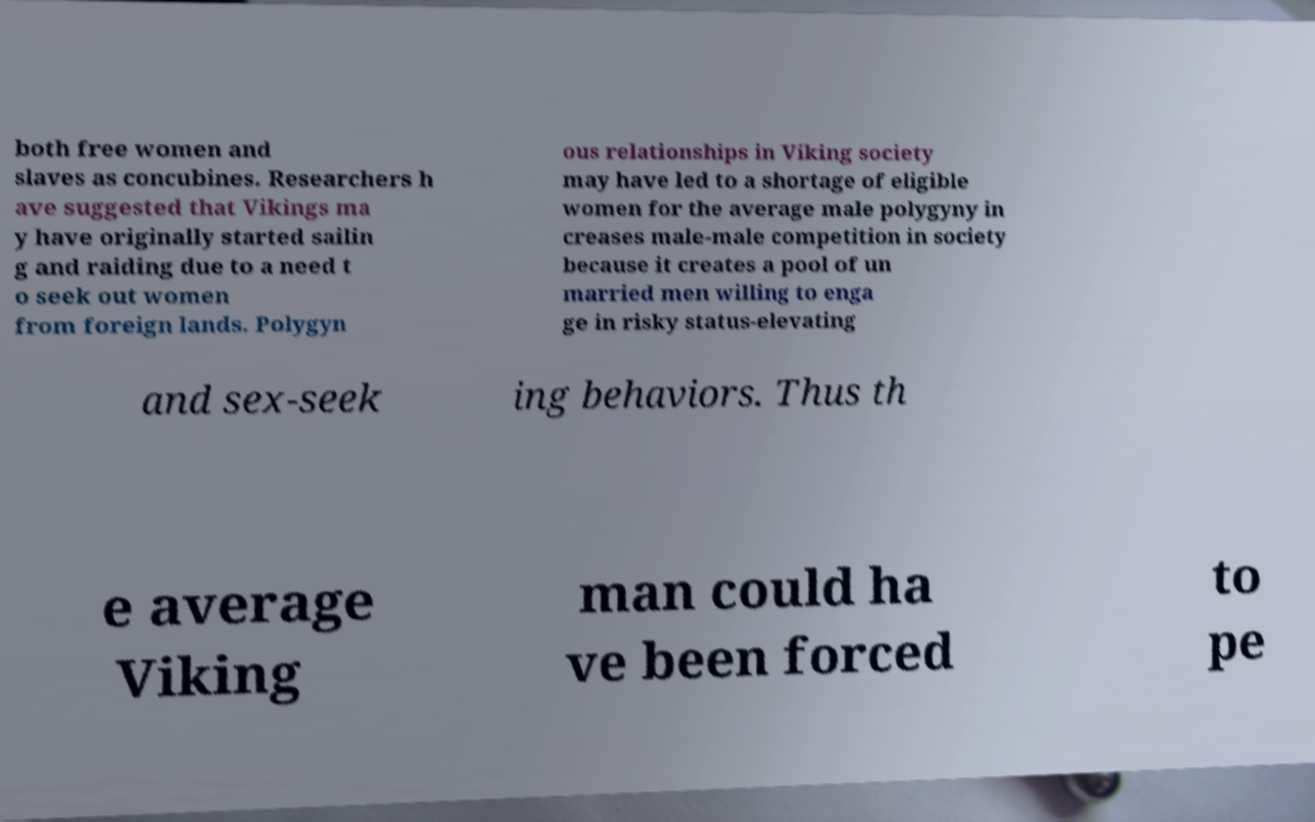For documentation purposes, I need the text within this image transcribed. Could you provide that? both free women and slaves as concubines. Researchers h ave suggested that Vikings ma y have originally started sailin g and raiding due to a need t o seek out women from foreign lands. Polygyn ous relationships in Viking society may have led to a shortage of eligible women for the average male polygyny in creases male-male competition in society because it creates a pool of un married men willing to enga ge in risky status-elevating and sex-seek ing behaviors. Thus th e average Viking man could ha ve been forced to pe 